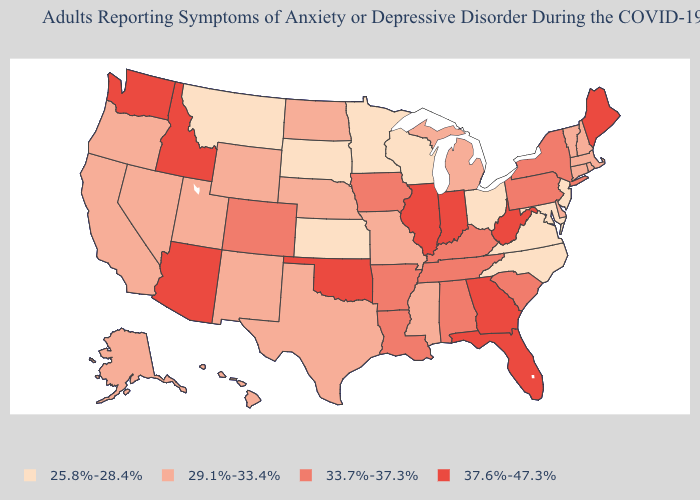What is the lowest value in states that border South Carolina?
Short answer required. 25.8%-28.4%. Does Kentucky have the highest value in the South?
Answer briefly. No. Is the legend a continuous bar?
Write a very short answer. No. What is the value of Missouri?
Write a very short answer. 29.1%-33.4%. Name the states that have a value in the range 33.7%-37.3%?
Write a very short answer. Alabama, Arkansas, Colorado, Iowa, Kentucky, Louisiana, New York, Pennsylvania, South Carolina, Tennessee. Which states have the lowest value in the USA?
Keep it brief. Kansas, Maryland, Minnesota, Montana, New Jersey, North Carolina, Ohio, South Dakota, Virginia, Wisconsin. What is the value of Indiana?
Be succinct. 37.6%-47.3%. What is the value of Mississippi?
Keep it brief. 29.1%-33.4%. Which states have the lowest value in the USA?
Concise answer only. Kansas, Maryland, Minnesota, Montana, New Jersey, North Carolina, Ohio, South Dakota, Virginia, Wisconsin. Does the map have missing data?
Be succinct. No. What is the value of Maryland?
Give a very brief answer. 25.8%-28.4%. What is the lowest value in the West?
Write a very short answer. 25.8%-28.4%. Does the map have missing data?
Answer briefly. No. 